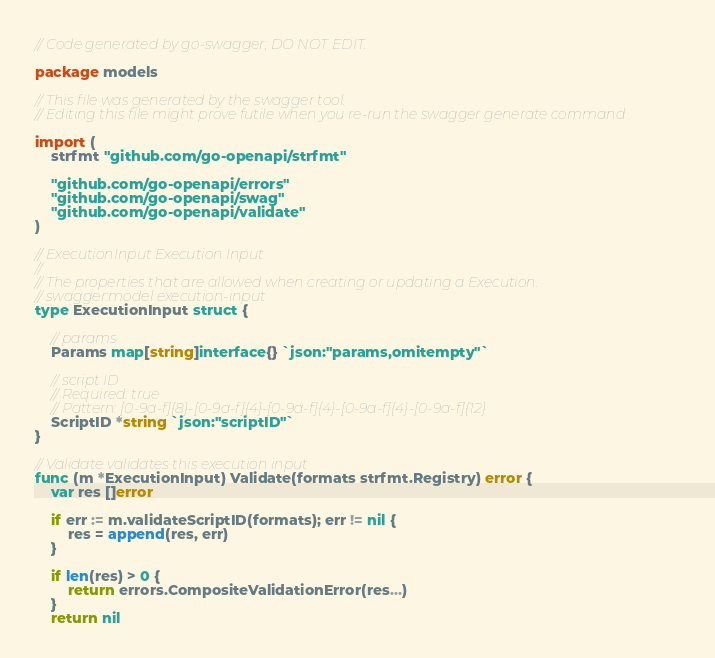Convert code to text. <code><loc_0><loc_0><loc_500><loc_500><_Go_>// Code generated by go-swagger; DO NOT EDIT.

package models

// This file was generated by the swagger tool.
// Editing this file might prove futile when you re-run the swagger generate command

import (
	strfmt "github.com/go-openapi/strfmt"

	"github.com/go-openapi/errors"
	"github.com/go-openapi/swag"
	"github.com/go-openapi/validate"
)

// ExecutionInput Execution Input
//
// The properties that are allowed when creating or updating a Execution.
// swagger:model execution-input
type ExecutionInput struct {

	// params
	Params map[string]interface{} `json:"params,omitempty"`

	// script ID
	// Required: true
	// Pattern: [0-9a-f]{8}-[0-9a-f]{4}-[0-9a-f]{4}-[0-9a-f]{4}-[0-9a-f]{12}
	ScriptID *string `json:"scriptID"`
}

// Validate validates this execution input
func (m *ExecutionInput) Validate(formats strfmt.Registry) error {
	var res []error

	if err := m.validateScriptID(formats); err != nil {
		res = append(res, err)
	}

	if len(res) > 0 {
		return errors.CompositeValidationError(res...)
	}
	return nil</code> 